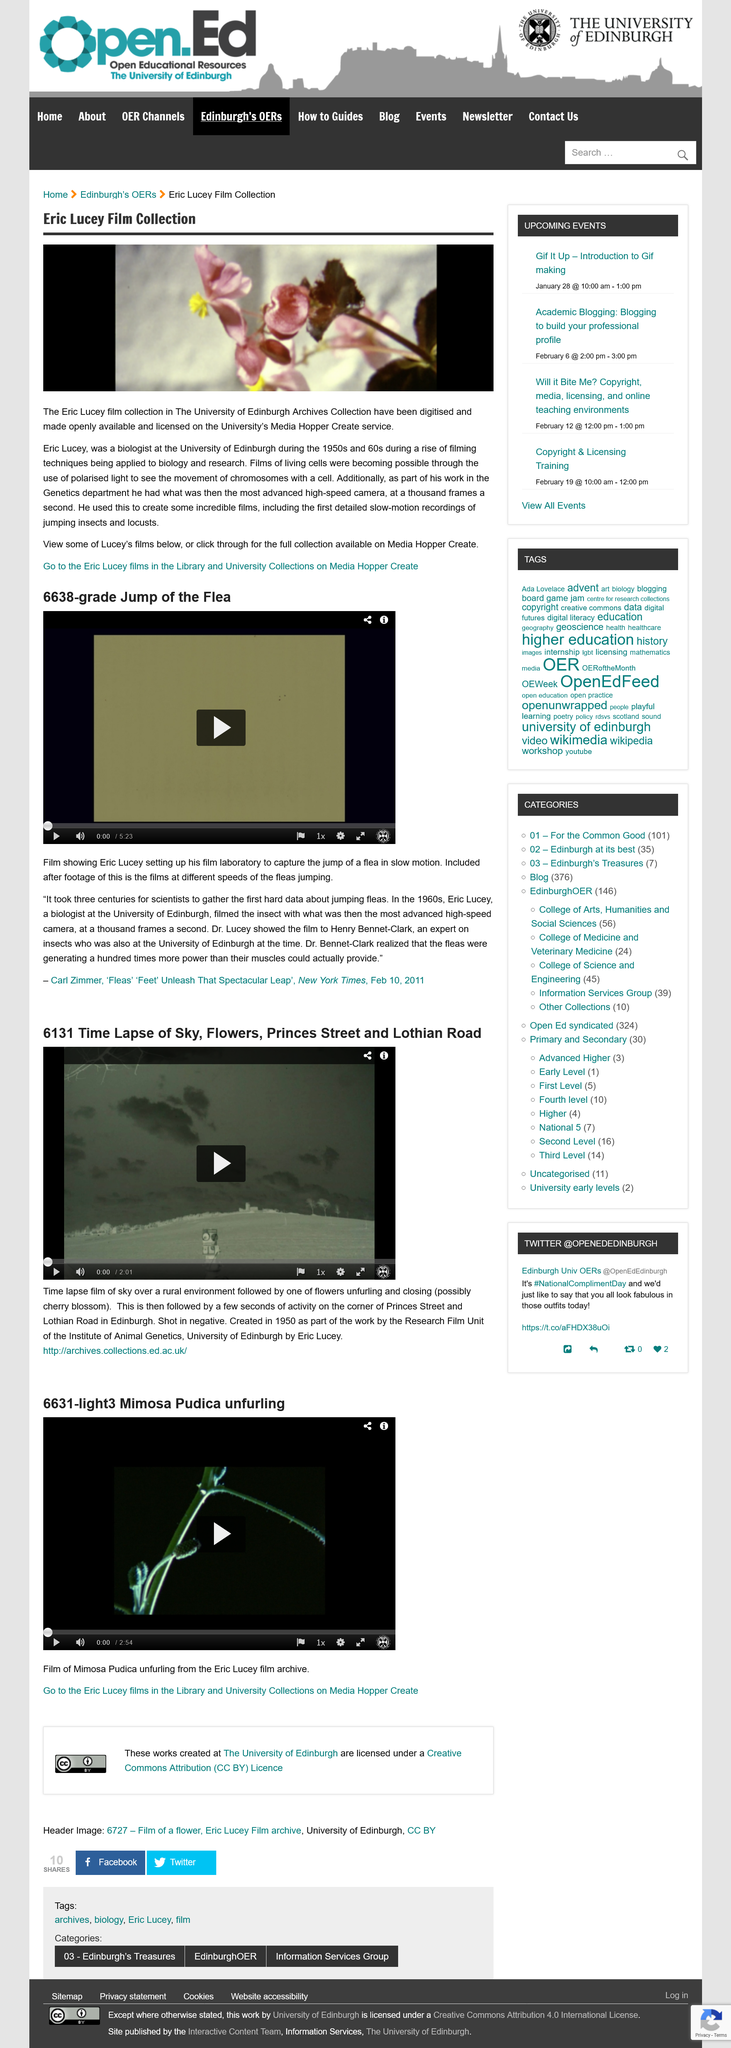Indicate a few pertinent items in this graphic. Eric Lucey was a biologist. Carl Zimmer wrote that 'Dr. Lucey showed the film to Henry Bennet-Clark.' The Eric Lucey Film collection is located in the University of Edinburgh archives. Eric Lucey was a biologist at the University of Edinburgh in the 1950's and 1960's. Henry Bennet-Clark was an expert on insects. 